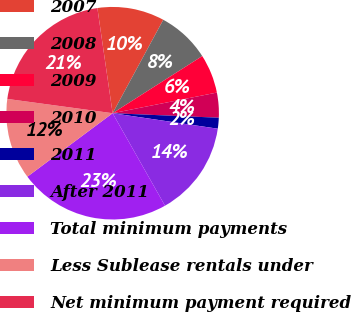Convert chart to OTSL. <chart><loc_0><loc_0><loc_500><loc_500><pie_chart><fcel>2007<fcel>2008<fcel>2009<fcel>2010<fcel>2011<fcel>After 2011<fcel>Total minimum payments<fcel>Less Sublease rentals under<fcel>Net minimum payment required<nl><fcel>10.2%<fcel>8.06%<fcel>5.92%<fcel>3.79%<fcel>1.65%<fcel>14.47%<fcel>23.02%<fcel>12.33%<fcel>20.56%<nl></chart> 